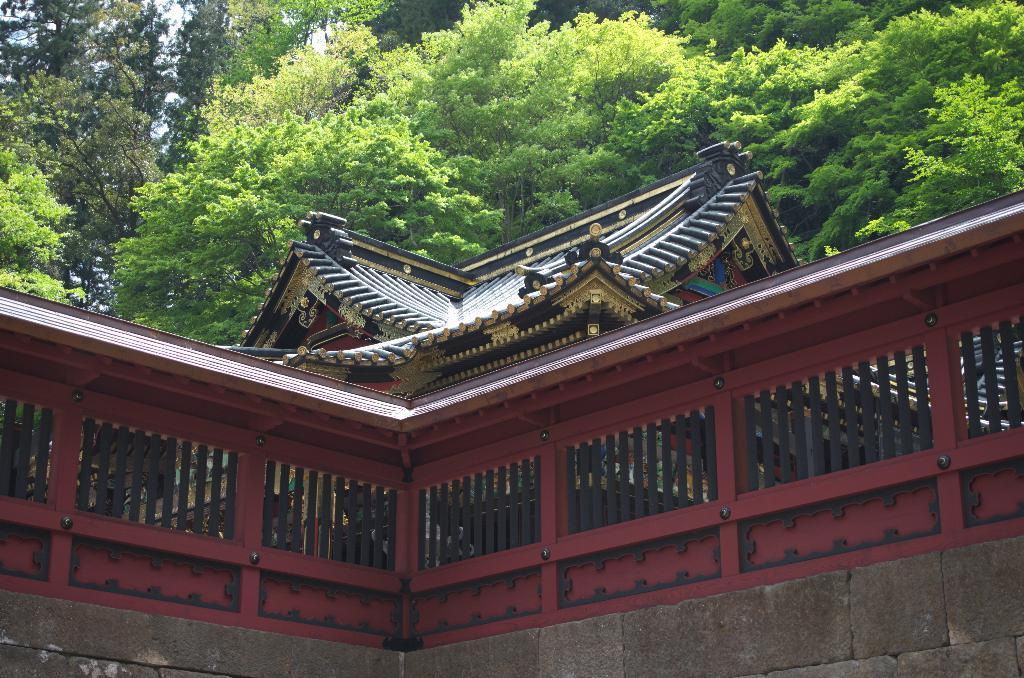What type of structure is visible in the image? There is a building in the image. What can be seen near the building? There is a grill in the image. What type of vegetation is present in the image? There are trees in the image. What type of loaf is being served on the spoon in the image? There is no loaf or spoon present in the image. 